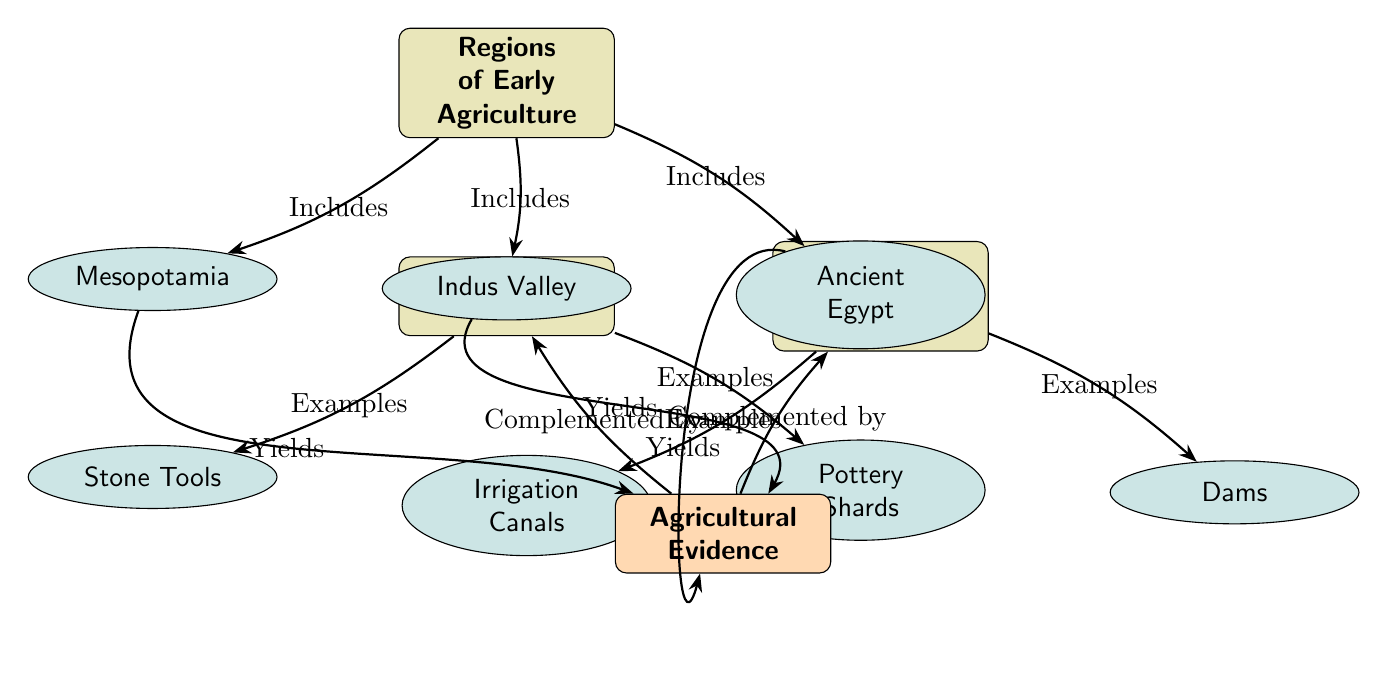What are the regions of early agriculture listed in the diagram? The diagram identifies three regions of early agriculture: Mesopotamia, Indus Valley, and Ancient Egypt, which are shown as sub-nodes branching from the main node "Regions of Early Agriculture."
Answer: Mesopotamia, Indus Valley, Ancient Egypt How many types of artifacts are mentioned in the diagram? The diagram lists two types of artifacts: Stone Tools and Pottery Shards, which are represented as sub-nodes under the "Artifacts" node.
Answer: 2 What types of water management systems are shown in the diagram? The diagram includes two examples of water management systems: Irrigation Canals and Dams, which are represented as sub-nodes under the "Water Management Systems" node.
Answer: Irrigation Canals, Dams What is the relationship between regions of early agriculture and agricultural evidence? The regions of early agriculture yield agricultural evidence, which is indicated by the edges connecting the regional nodes to the "Agricultural Evidence" node in the diagram.
Answer: Yields Which node states that agricultural evidence is complemented by artifacts? The arrow from the "Agricultural Evidence" node to the "Artifacts" node clearly states that agricultural evidence is complemented by artifacts, as indicated by the text along the connecting edge.
Answer: Artifacts How is the agricultural evidence interconnected with other evidence types according to the diagram? The diagram shows that agricultural evidence complements artifacts and water management systems, establishing a relationship where these elements support understanding of agriculture's spread.
Answer: Complemented by artifacts and water What main node is located at the top of the diagram? The top main node is labeled "Regions of Early Agriculture," serving as the central focus from which the interconnected elements branch out below.
Answer: Regions of Early Agriculture What does the edge from Ancient Egypt point towards? The edge from Ancient Egypt points towards the "Agricultural Evidence" node, indicating that this region produces evidence related to agriculture.
Answer: Agricultural Evidence 